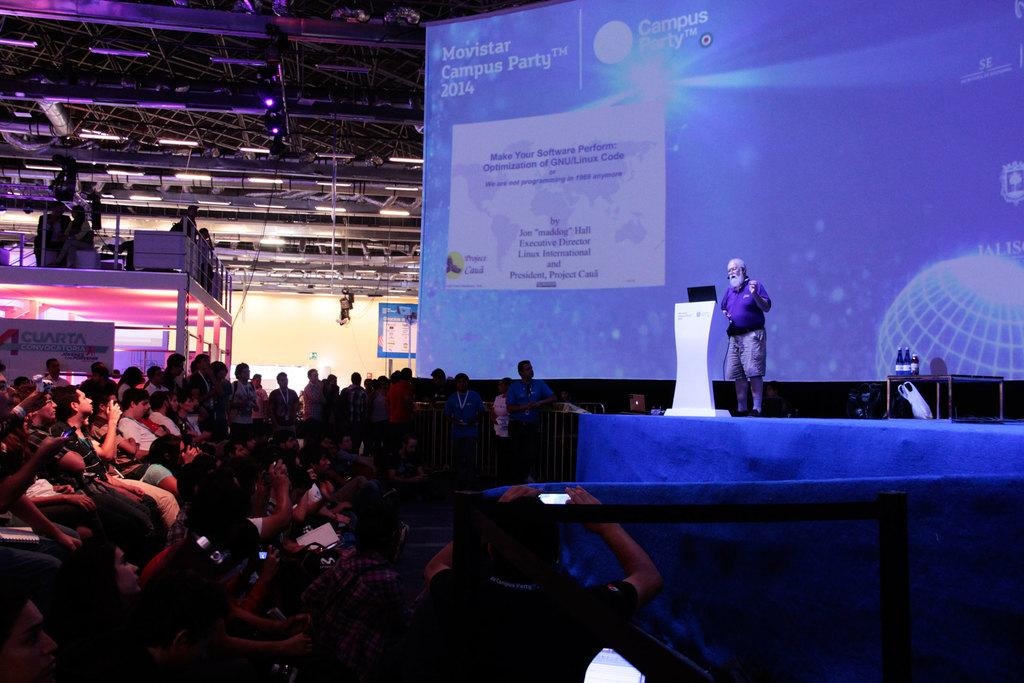Who is the main subject in the picture? There is an old man in the picture. Where is the old man located in the image? The old man is standing on a stage. What are the people in the image doing? The people are sitting down the stage and watching the old man. What type of stone can be seen in the picture? There is no stone present in the picture; it features an old man standing on a stage with people watching him. What kind of print is visible on the old man's clothing? The old man's clothing is not described in the provided facts, so it is impossible to determine if there is any print on it. 